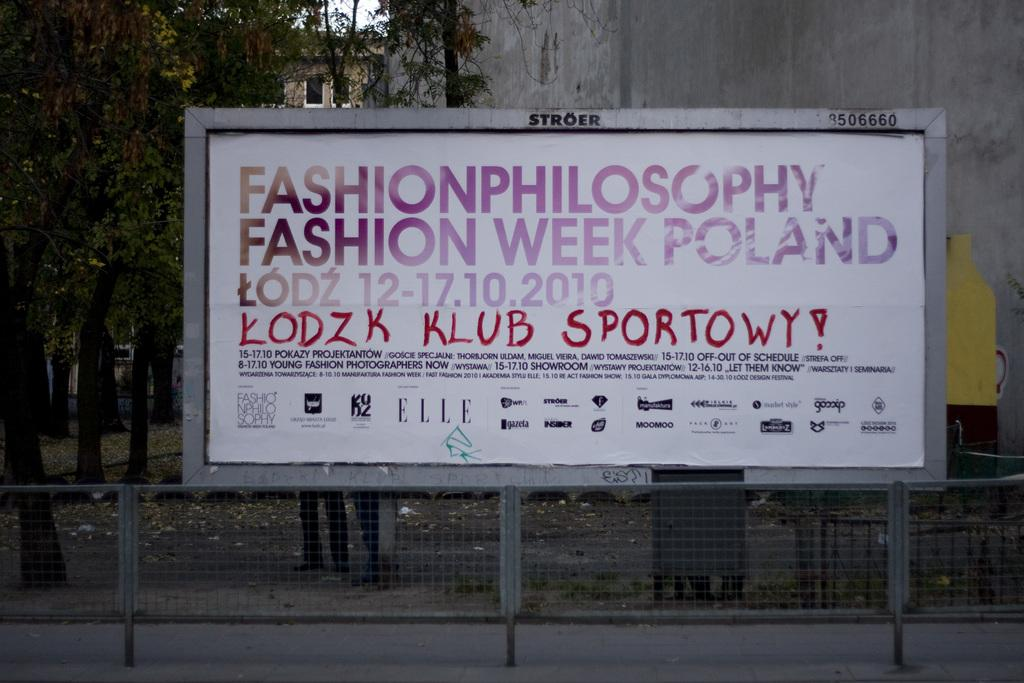<image>
Relay a brief, clear account of the picture shown. A large hoarding advertising a fashion week in Poland has graffiti on it written in red ink. 